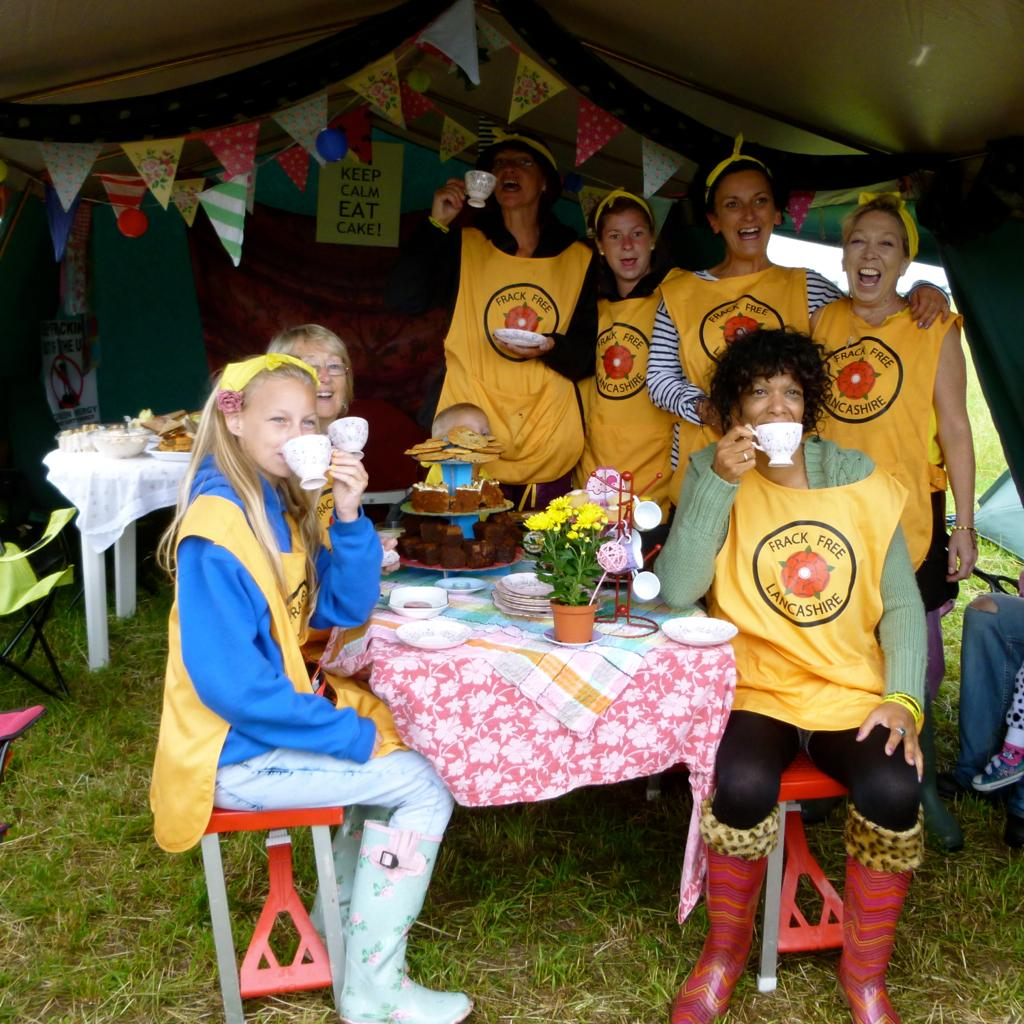Who or what is present in the image? There are people in the image. What is the primary object in the image? There is a table in the image. What can be found on the table? There is a flower flask and a cake on the table. Are there any additional items on the table? Yes, there are plates on the table. What type of joke is being told by the people in the image? There is no indication of a joke being told in the image; it only shows people, a table, a flower flask, a cake, and plates. 